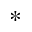Convert formula to latex. <formula><loc_0><loc_0><loc_500><loc_500>^ { \ast }</formula> 